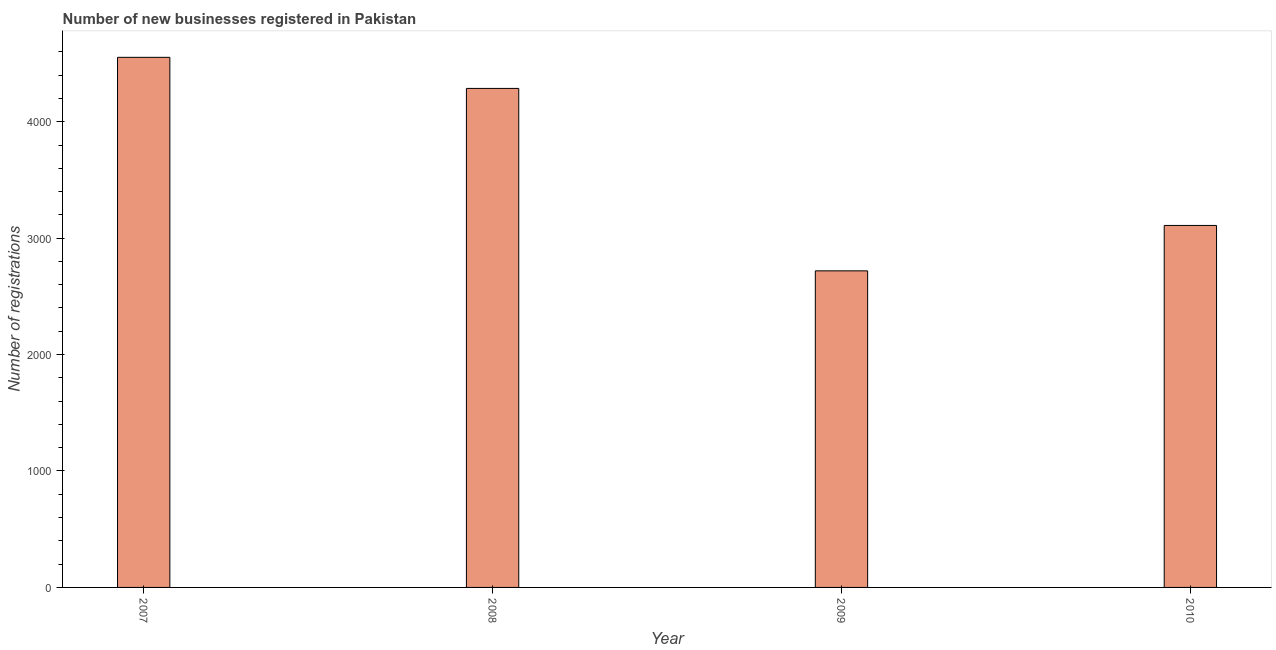Does the graph contain any zero values?
Keep it short and to the point. No. Does the graph contain grids?
Offer a terse response. No. What is the title of the graph?
Give a very brief answer. Number of new businesses registered in Pakistan. What is the label or title of the X-axis?
Provide a succinct answer. Year. What is the label or title of the Y-axis?
Make the answer very short. Number of registrations. What is the number of new business registrations in 2007?
Ensure brevity in your answer.  4553. Across all years, what is the maximum number of new business registrations?
Offer a very short reply. 4553. Across all years, what is the minimum number of new business registrations?
Your answer should be very brief. 2719. What is the sum of the number of new business registrations?
Provide a succinct answer. 1.47e+04. What is the difference between the number of new business registrations in 2008 and 2009?
Your response must be concise. 1567. What is the average number of new business registrations per year?
Make the answer very short. 3666. What is the median number of new business registrations?
Your answer should be very brief. 3697.5. In how many years, is the number of new business registrations greater than 3200 ?
Provide a short and direct response. 2. What is the ratio of the number of new business registrations in 2007 to that in 2008?
Provide a succinct answer. 1.06. Is the number of new business registrations in 2007 less than that in 2008?
Offer a very short reply. No. What is the difference between the highest and the second highest number of new business registrations?
Make the answer very short. 267. What is the difference between the highest and the lowest number of new business registrations?
Make the answer very short. 1834. Are all the bars in the graph horizontal?
Offer a very short reply. No. What is the Number of registrations in 2007?
Provide a short and direct response. 4553. What is the Number of registrations of 2008?
Make the answer very short. 4286. What is the Number of registrations of 2009?
Give a very brief answer. 2719. What is the Number of registrations in 2010?
Ensure brevity in your answer.  3109. What is the difference between the Number of registrations in 2007 and 2008?
Make the answer very short. 267. What is the difference between the Number of registrations in 2007 and 2009?
Make the answer very short. 1834. What is the difference between the Number of registrations in 2007 and 2010?
Offer a very short reply. 1444. What is the difference between the Number of registrations in 2008 and 2009?
Make the answer very short. 1567. What is the difference between the Number of registrations in 2008 and 2010?
Offer a very short reply. 1177. What is the difference between the Number of registrations in 2009 and 2010?
Offer a terse response. -390. What is the ratio of the Number of registrations in 2007 to that in 2008?
Offer a terse response. 1.06. What is the ratio of the Number of registrations in 2007 to that in 2009?
Your answer should be compact. 1.68. What is the ratio of the Number of registrations in 2007 to that in 2010?
Provide a short and direct response. 1.46. What is the ratio of the Number of registrations in 2008 to that in 2009?
Provide a succinct answer. 1.58. What is the ratio of the Number of registrations in 2008 to that in 2010?
Your answer should be compact. 1.38. 